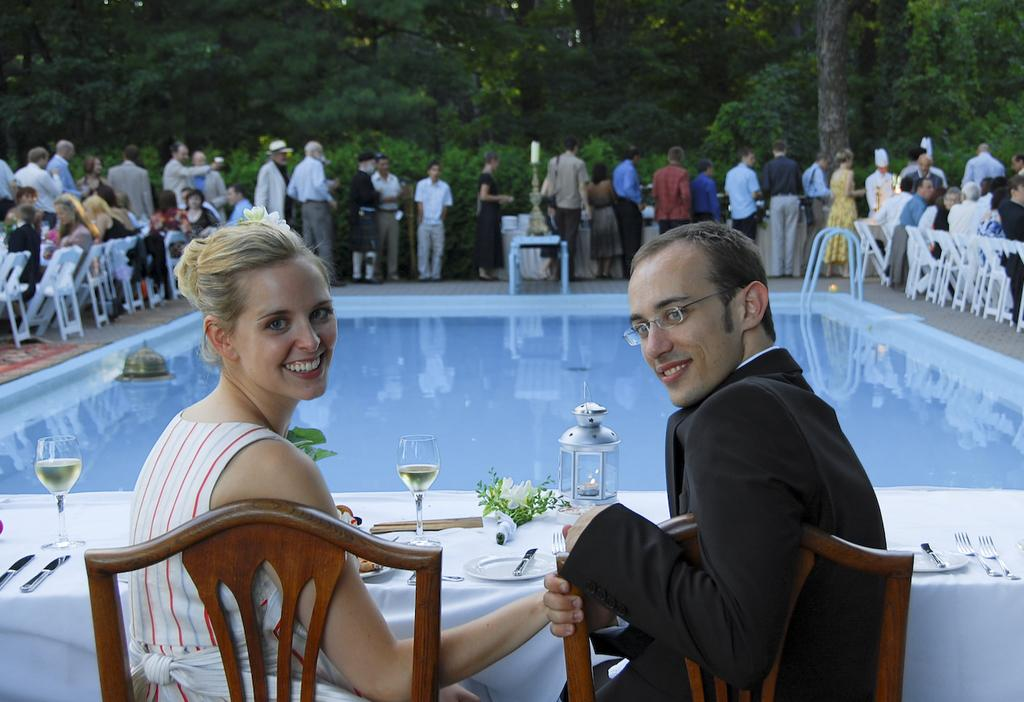What is the main feature in the image? There is a swimming pool in the image. What are the people around the swimming pool doing? The people are sitting and standing around the swimming pool. What can be seen in the background of the image? There are trees in the background of the image. How many hens are sitting on the edge of the swimming pool in the image? There are no hens present in the image. What type of finger is being used to point at the trees in the background? There is no finger pointing at the trees in the background, as the image does not show any fingers. 